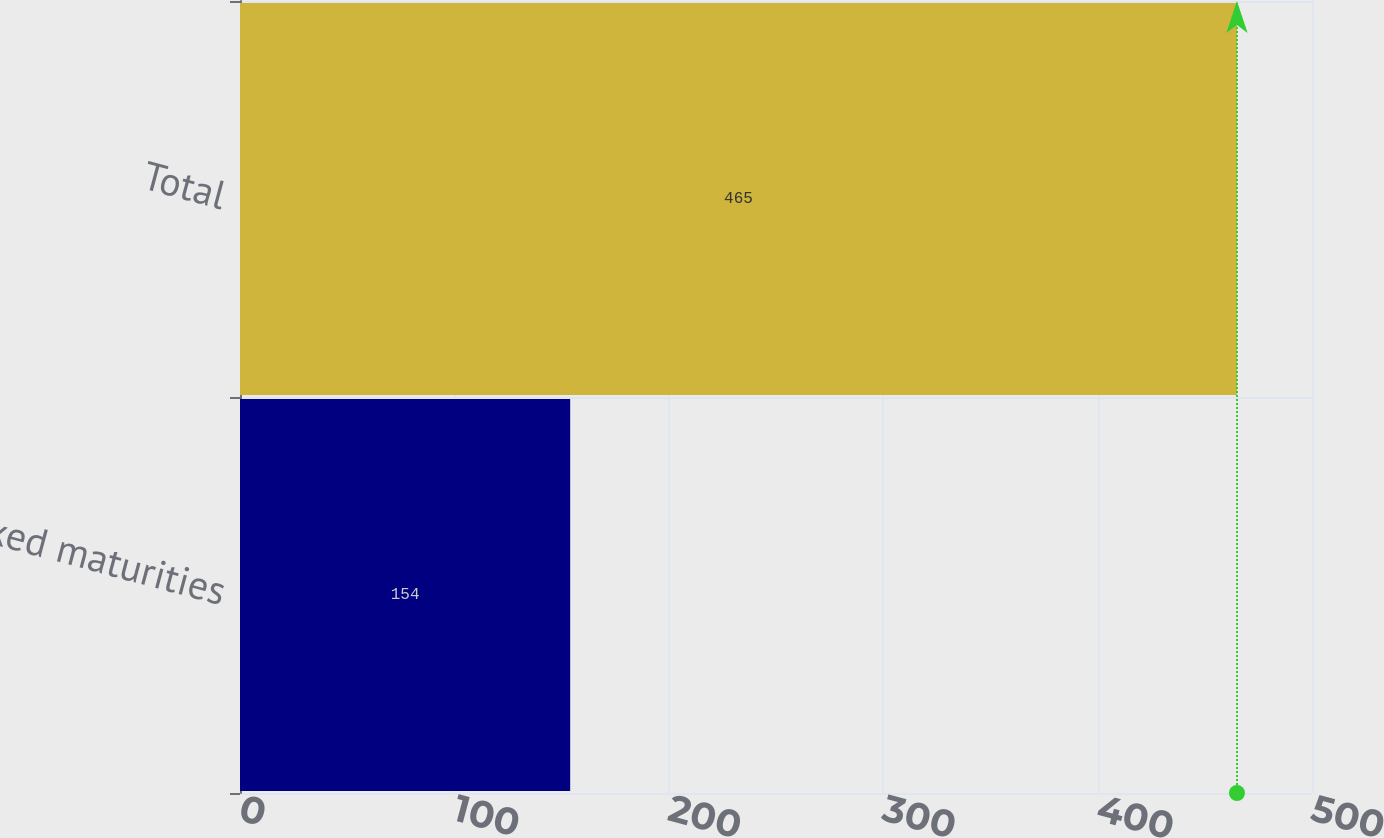Convert chart to OTSL. <chart><loc_0><loc_0><loc_500><loc_500><bar_chart><fcel>Fixed maturities<fcel>Total<nl><fcel>154<fcel>465<nl></chart> 